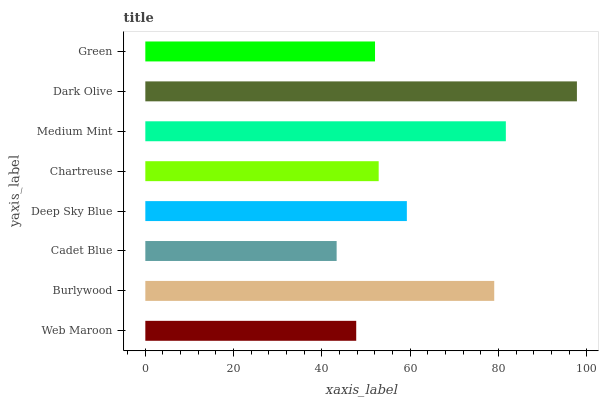Is Cadet Blue the minimum?
Answer yes or no. Yes. Is Dark Olive the maximum?
Answer yes or no. Yes. Is Burlywood the minimum?
Answer yes or no. No. Is Burlywood the maximum?
Answer yes or no. No. Is Burlywood greater than Web Maroon?
Answer yes or no. Yes. Is Web Maroon less than Burlywood?
Answer yes or no. Yes. Is Web Maroon greater than Burlywood?
Answer yes or no. No. Is Burlywood less than Web Maroon?
Answer yes or no. No. Is Deep Sky Blue the high median?
Answer yes or no. Yes. Is Chartreuse the low median?
Answer yes or no. Yes. Is Chartreuse the high median?
Answer yes or no. No. Is Green the low median?
Answer yes or no. No. 